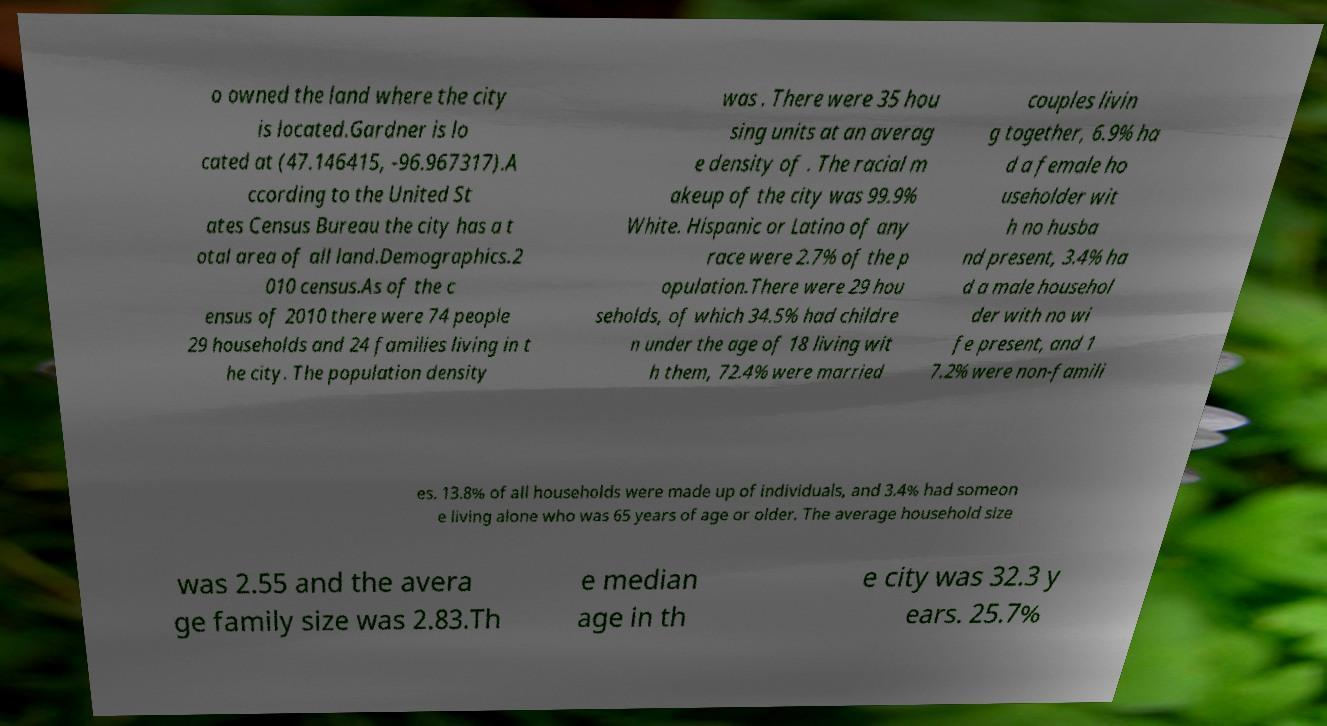Can you accurately transcribe the text from the provided image for me? o owned the land where the city is located.Gardner is lo cated at (47.146415, -96.967317).A ccording to the United St ates Census Bureau the city has a t otal area of all land.Demographics.2 010 census.As of the c ensus of 2010 there were 74 people 29 households and 24 families living in t he city. The population density was . There were 35 hou sing units at an averag e density of . The racial m akeup of the city was 99.9% White. Hispanic or Latino of any race were 2.7% of the p opulation.There were 29 hou seholds, of which 34.5% had childre n under the age of 18 living wit h them, 72.4% were married couples livin g together, 6.9% ha d a female ho useholder wit h no husba nd present, 3.4% ha d a male househol der with no wi fe present, and 1 7.2% were non-famili es. 13.8% of all households were made up of individuals, and 3.4% had someon e living alone who was 65 years of age or older. The average household size was 2.55 and the avera ge family size was 2.83.Th e median age in th e city was 32.3 y ears. 25.7% 